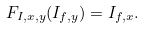Convert formula to latex. <formula><loc_0><loc_0><loc_500><loc_500>F _ { I , x , y } ( I _ { f , y } ) = I _ { f , x } .</formula> 